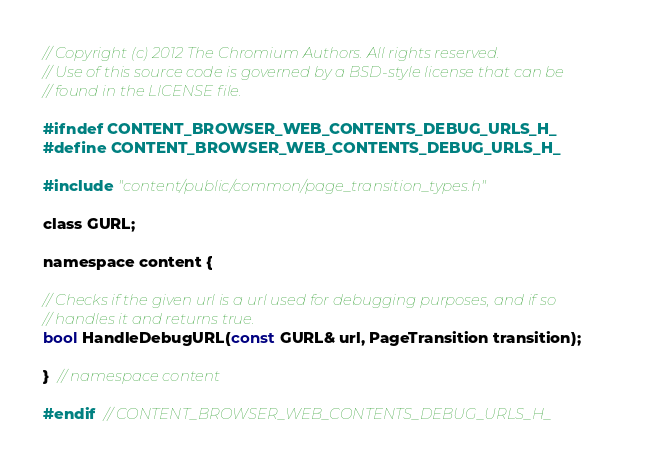<code> <loc_0><loc_0><loc_500><loc_500><_C_>// Copyright (c) 2012 The Chromium Authors. All rights reserved.
// Use of this source code is governed by a BSD-style license that can be
// found in the LICENSE file.

#ifndef CONTENT_BROWSER_WEB_CONTENTS_DEBUG_URLS_H_
#define CONTENT_BROWSER_WEB_CONTENTS_DEBUG_URLS_H_

#include "content/public/common/page_transition_types.h"

class GURL;

namespace content {

// Checks if the given url is a url used for debugging purposes, and if so
// handles it and returns true.
bool HandleDebugURL(const GURL& url, PageTransition transition);

}  // namespace content

#endif  // CONTENT_BROWSER_WEB_CONTENTS_DEBUG_URLS_H_
</code> 